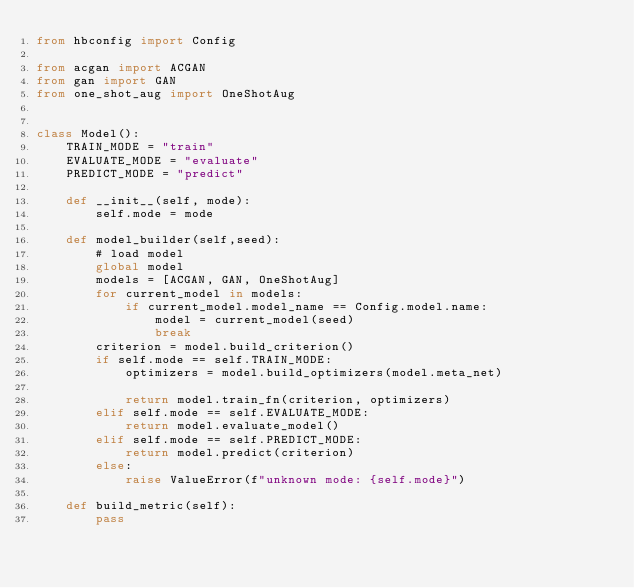<code> <loc_0><loc_0><loc_500><loc_500><_Python_>from hbconfig import Config

from acgan import ACGAN
from gan import GAN
from one_shot_aug import OneShotAug


class Model():
	TRAIN_MODE = "train"
	EVALUATE_MODE = "evaluate"
	PREDICT_MODE = "predict"
	
	def __init__(self, mode):
		self.mode = mode
	
	def model_builder(self,seed):
		# load model
		global model
		models = [ACGAN, GAN, OneShotAug]
		for current_model in models:
			if current_model.model_name == Config.model.name:
				model = current_model(seed)
				break
		criterion = model.build_criterion()
		if self.mode == self.TRAIN_MODE:
			optimizers = model.build_optimizers(model.meta_net)
			
			return model.train_fn(criterion, optimizers)
		elif self.mode == self.EVALUATE_MODE:
			return model.evaluate_model()
		elif self.mode == self.PREDICT_MODE:
			return model.predict(criterion)
		else:
			raise ValueError(f"unknown mode: {self.mode}")
	
	def build_metric(self):
		pass
</code> 